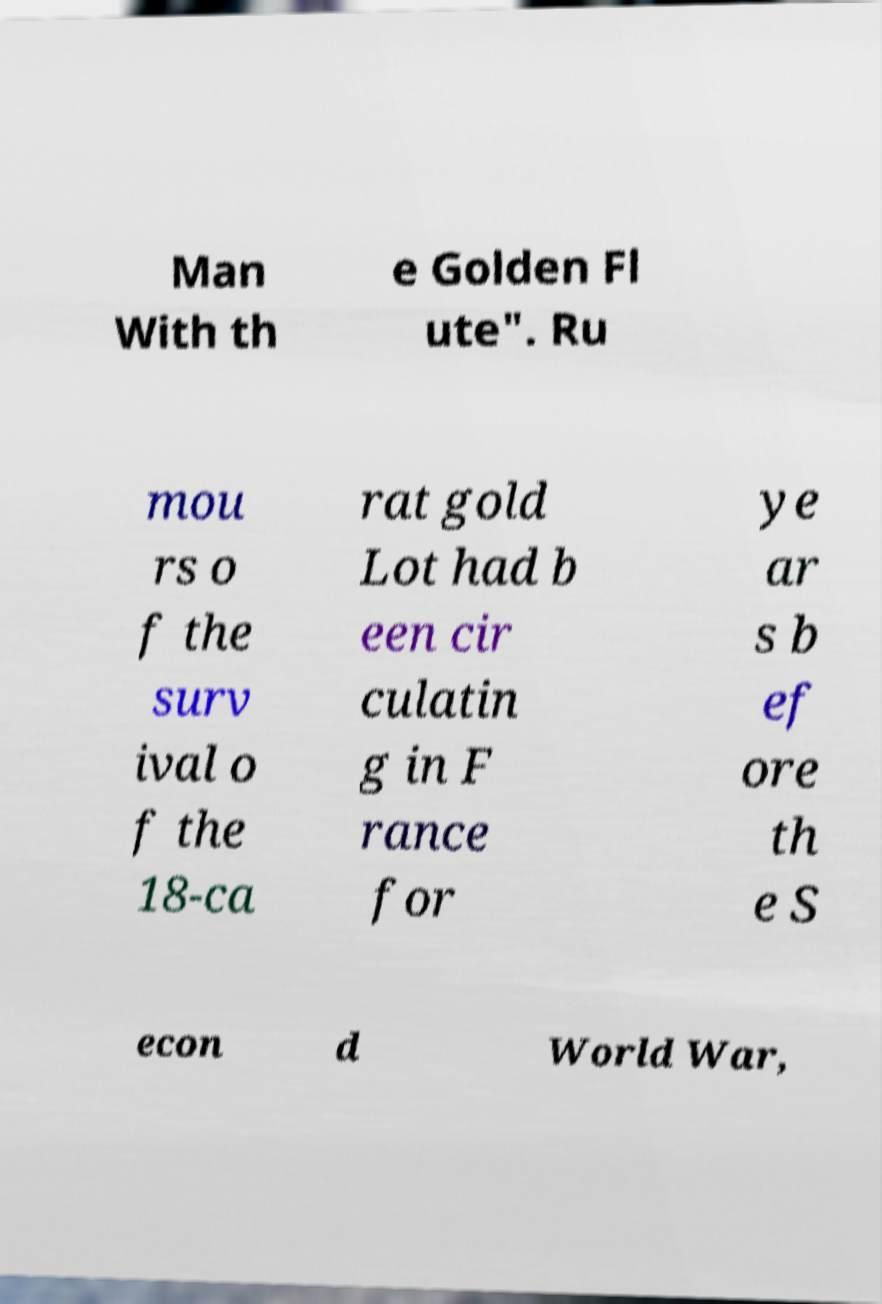Please read and relay the text visible in this image. What does it say? Man With th e Golden Fl ute". Ru mou rs o f the surv ival o f the 18-ca rat gold Lot had b een cir culatin g in F rance for ye ar s b ef ore th e S econ d World War, 